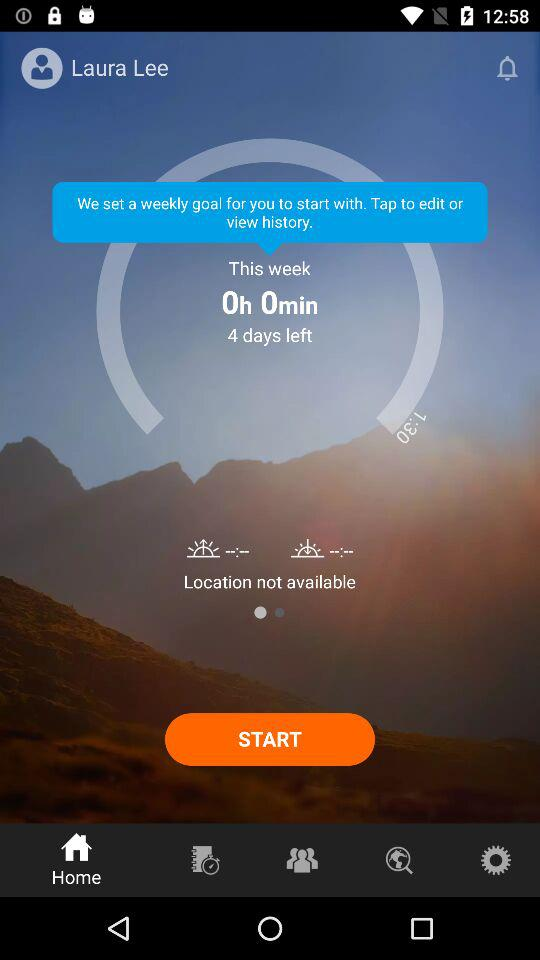What's the user name? The user name is Laura Lee. 